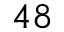Convert formula to latex. <formula><loc_0><loc_0><loc_500><loc_500>4 8</formula> 